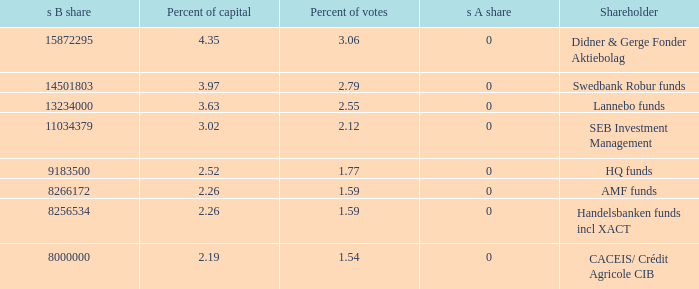What is the percent of capital for the shareholder that has a s B share of 8256534?  2.26. 